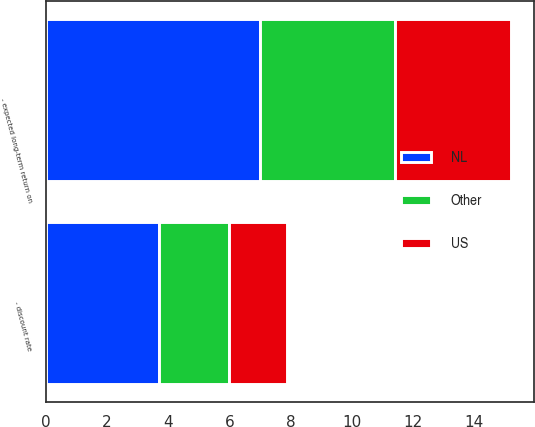Convert chart to OTSL. <chart><loc_0><loc_0><loc_500><loc_500><stacked_bar_chart><ecel><fcel>- discount rate<fcel>- expected long-term return on<nl><fcel>US<fcel>1.9<fcel>3.8<nl><fcel>NL<fcel>3.7<fcel>7<nl><fcel>Other<fcel>2.3<fcel>4.4<nl></chart> 